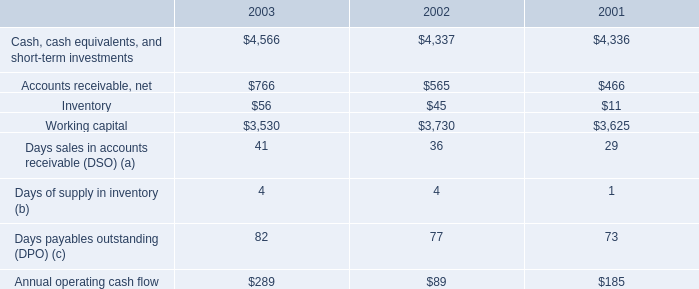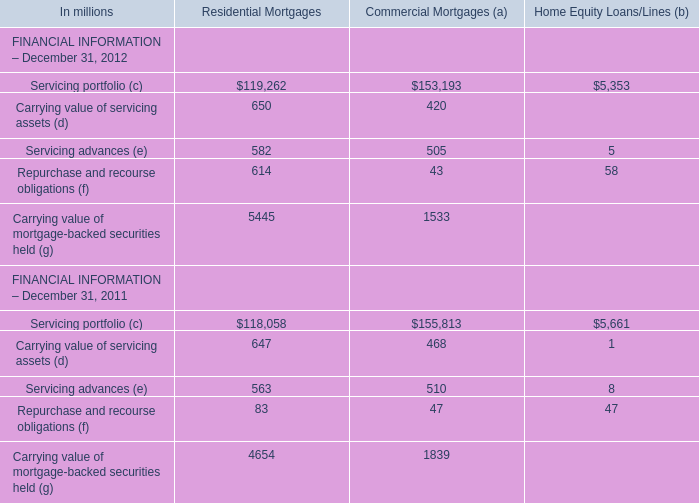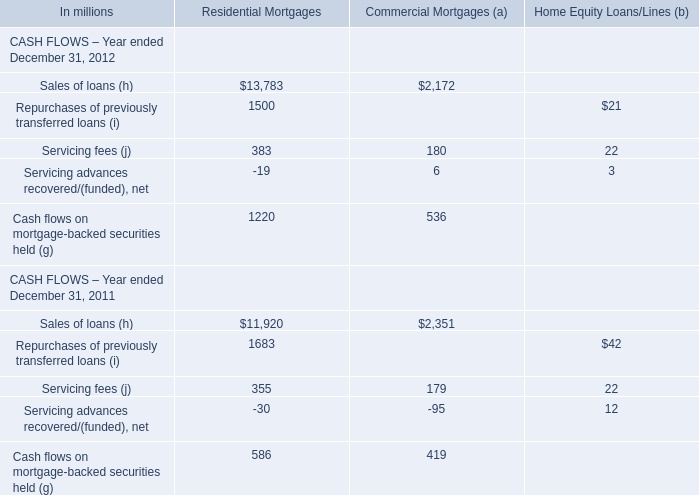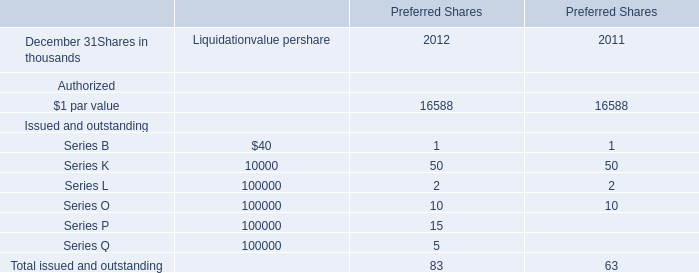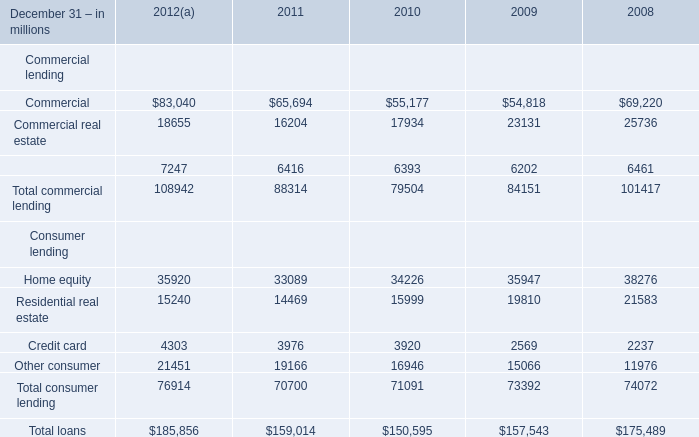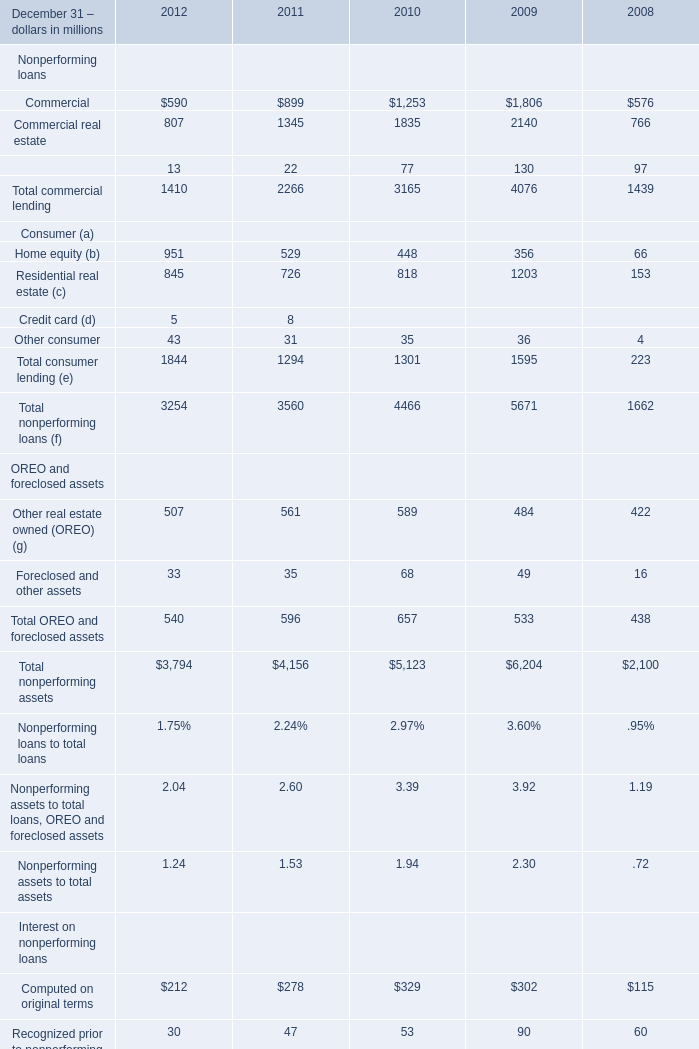What was the total amount of Commercial in 2012 and 2011? 
Computations: (590 + 899)
Answer: 1489.0. 